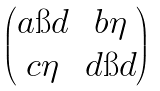Convert formula to latex. <formula><loc_0><loc_0><loc_500><loc_500>\begin{pmatrix} a \i d & b \eta \\ c \eta & d \i d \end{pmatrix}</formula> 